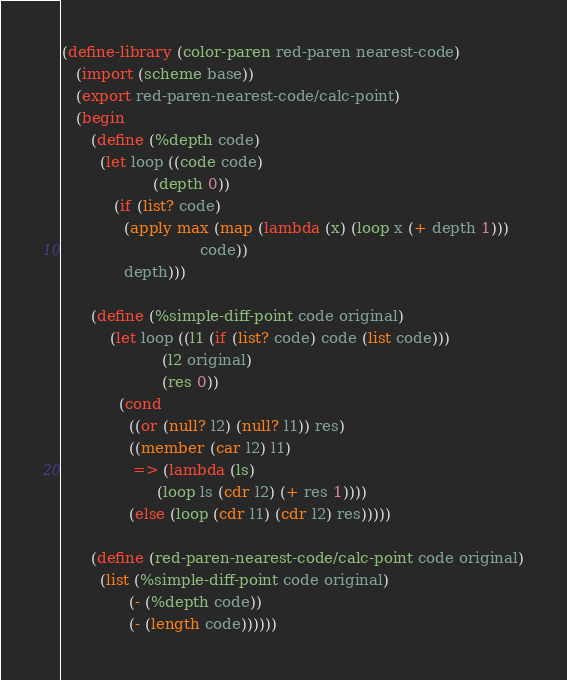Convert code to text. <code><loc_0><loc_0><loc_500><loc_500><_Scheme_>(define-library (color-paren red-paren nearest-code)
   (import (scheme base))
   (export red-paren-nearest-code/calc-point)
   (begin
      (define (%depth code)
        (let loop ((code code)
                   (depth 0))
           (if (list? code)
             (apply max (map (lambda (x) (loop x (+ depth 1)))
                             code))
             depth)))

      (define (%simple-diff-point code original)
          (let loop ((l1 (if (list? code) code (list code)))
                     (l2 original)
                     (res 0))
            (cond
              ((or (null? l2) (null? l1)) res)
              ((member (car l2) l1)
               => (lambda (ls)
                    (loop ls (cdr l2) (+ res 1))))
              (else (loop (cdr l1) (cdr l2) res)))))

      (define (red-paren-nearest-code/calc-point code original)
        (list (%simple-diff-point code original)
              (- (%depth code))
              (- (length code))))))
</code> 